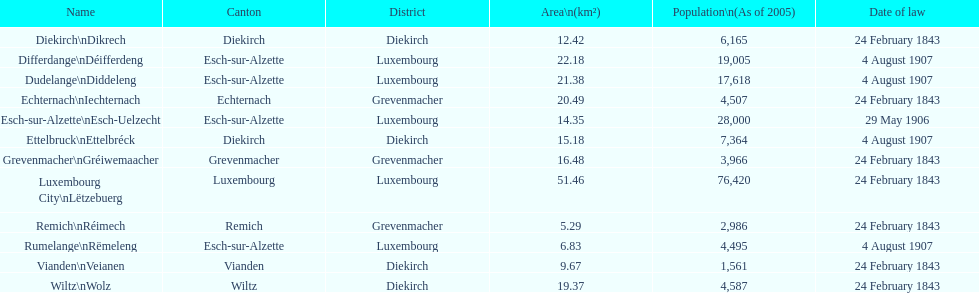What canton is the most populated? Luxembourg. 